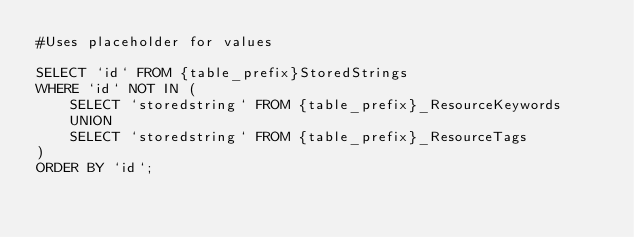<code> <loc_0><loc_0><loc_500><loc_500><_SQL_>#Uses placeholder for values

SELECT `id` FROM {table_prefix}StoredStrings
WHERE `id` NOT IN (
	SELECT `storedstring` FROM {table_prefix}_ResourceKeywords
    UNION
    SELECT `storedstring` FROM {table_prefix}_ResourceTags
)
ORDER BY `id`;</code> 